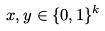Convert formula to latex. <formula><loc_0><loc_0><loc_500><loc_500>x , y \in \{ 0 , 1 \} ^ { k }</formula> 